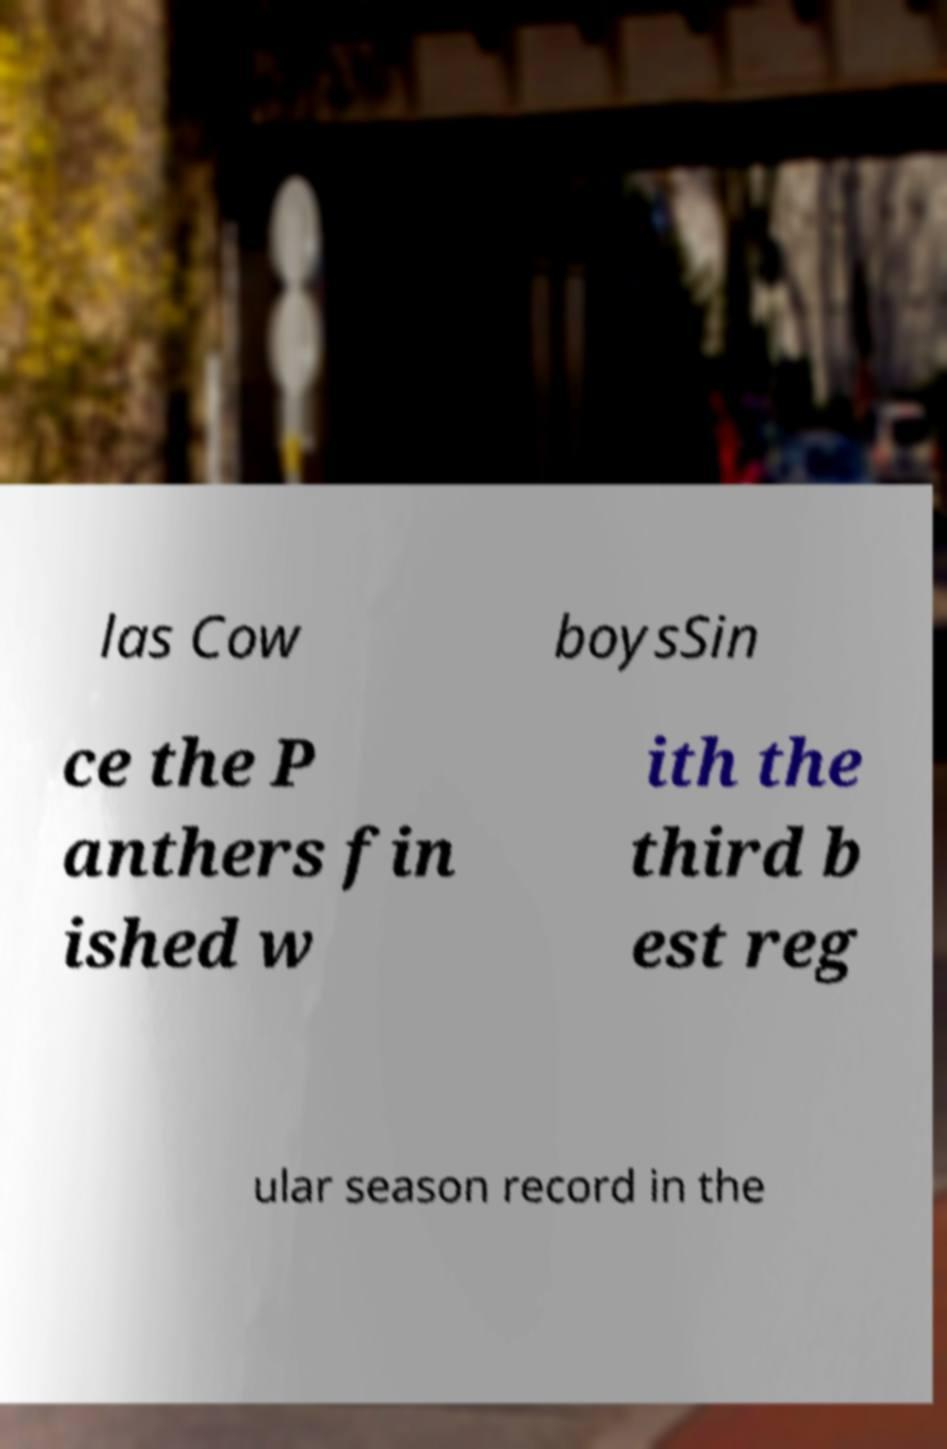For documentation purposes, I need the text within this image transcribed. Could you provide that? las Cow boysSin ce the P anthers fin ished w ith the third b est reg ular season record in the 